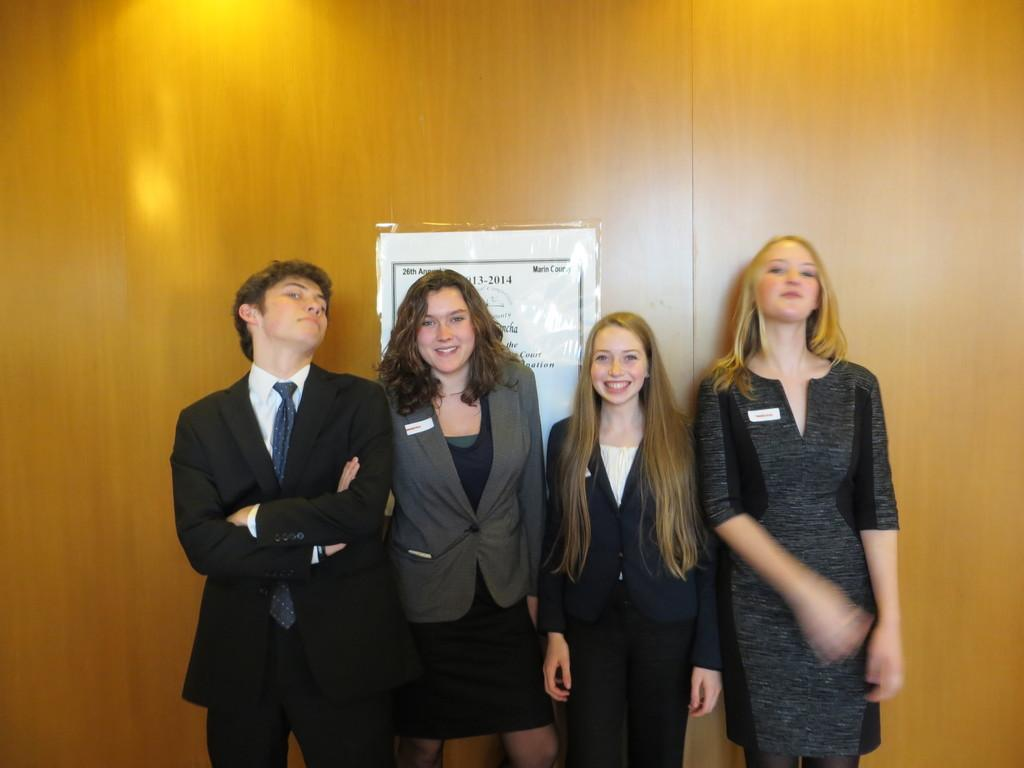How many people are in the image? There are four people in the image. What are the people doing in the image? The people are standing and smiling. What can be seen in the background of the image? There is a wooden wall in the background of the image. What is on the wooden wall? There is a poster on the wall. What type of prose can be heard being read aloud in the image? There is no indication in the image that anyone is reading aloud, nor is there any reference to prose. --- 